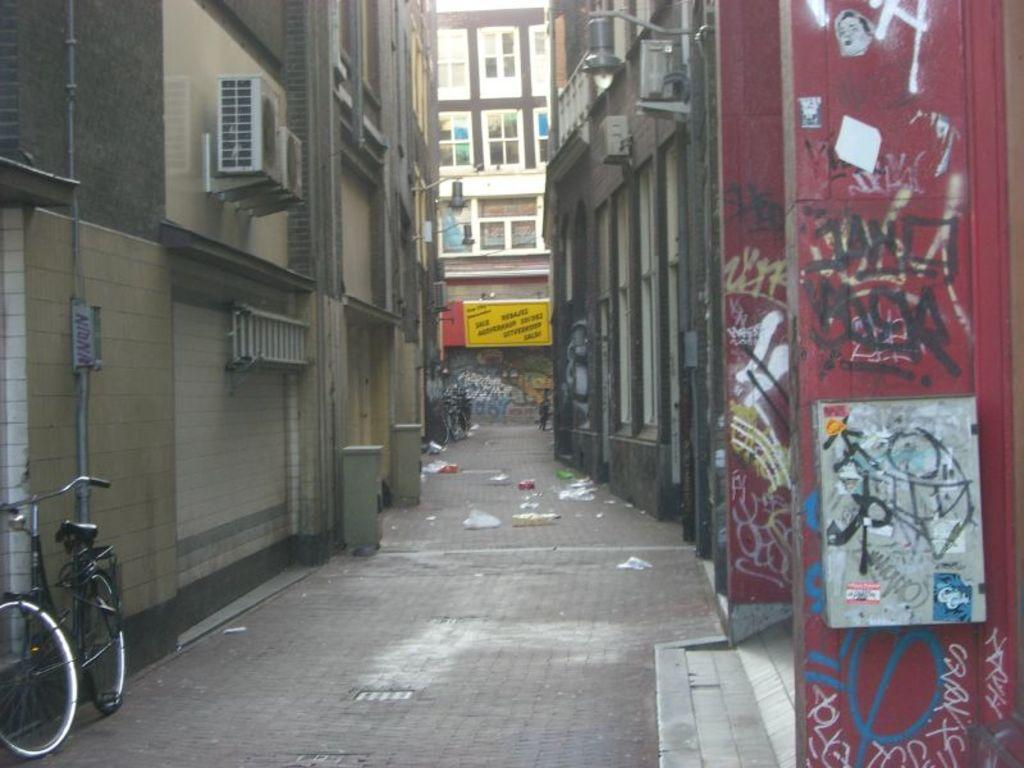What type of structures can be seen in the image? There are buildings in the image. What mode of transportation is present in the image? There is a bicycle in the image. What can be found on the road in the image? There are other objects on the road in the image. What feature is visible on the buildings in the image? There are windows visible in the image. What can be seen on the walls in the image? There are other objects on walls in the image. Can you hear a whistle in the image? There is no auditory information provided in the image, so it is impossible to determine if a whistle can be heard. How many trains are visible in the image? There are no trains present in the image. 